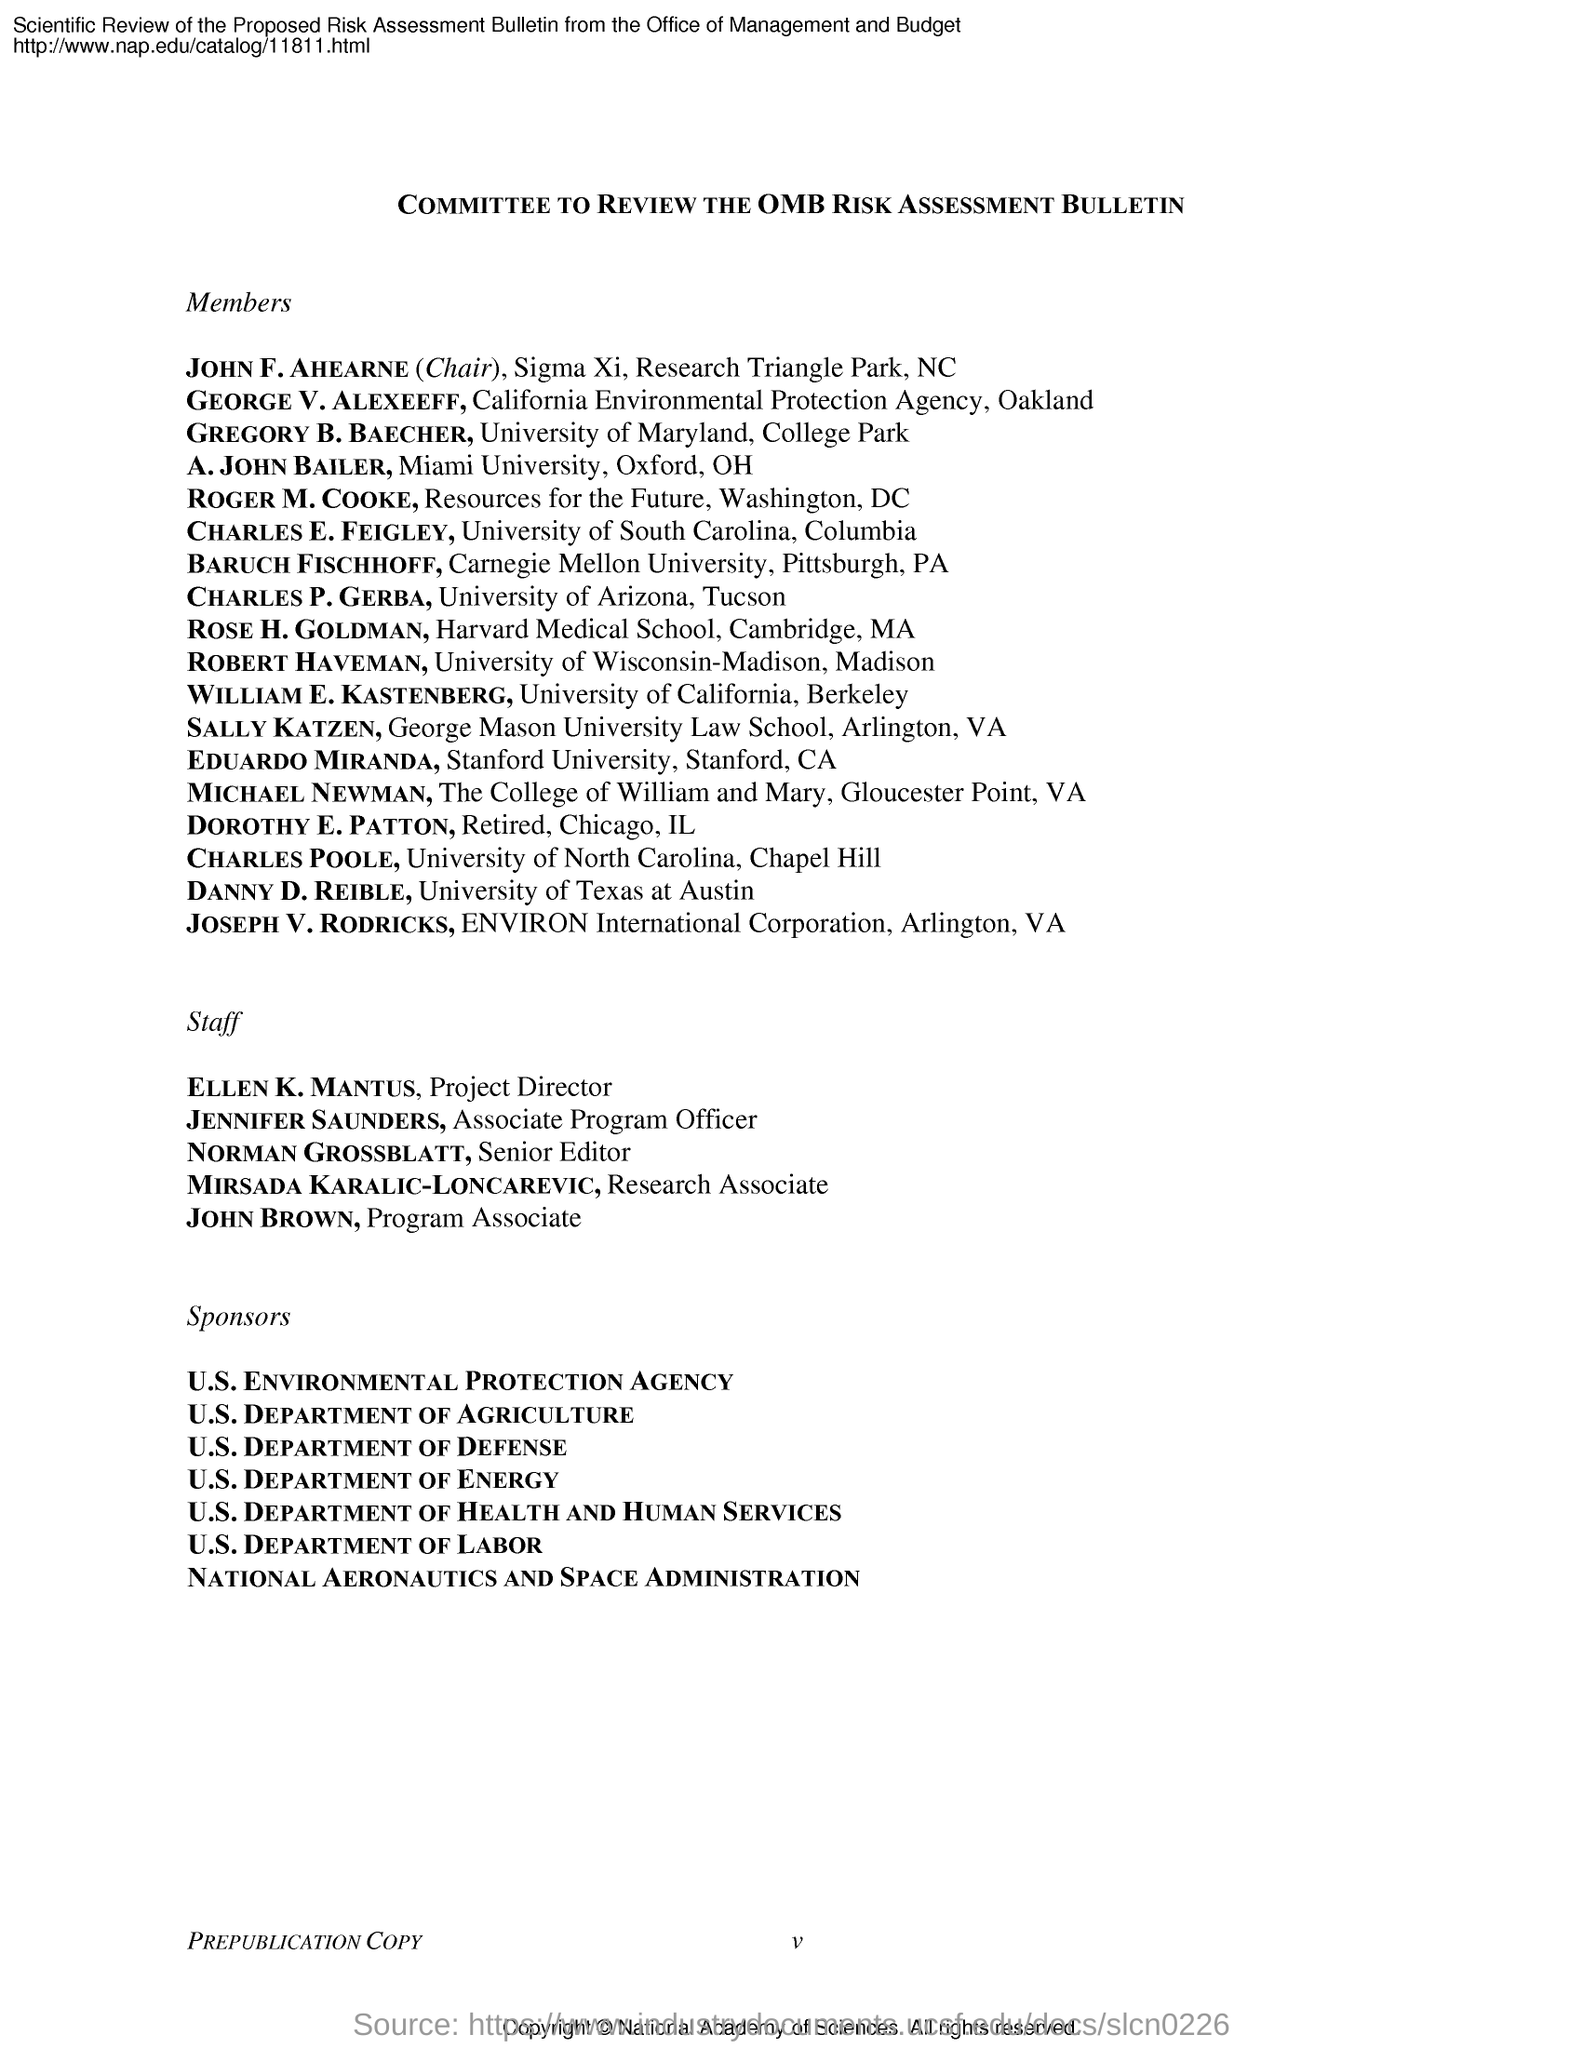Who is the project director?
Your answer should be very brief. Ellen K. Mantus. Who is the program associate?
Provide a succinct answer. JOHN BROWN. What is the designation of Norman Grossblatt?
Your answer should be compact. SENIOR EDITOR. 